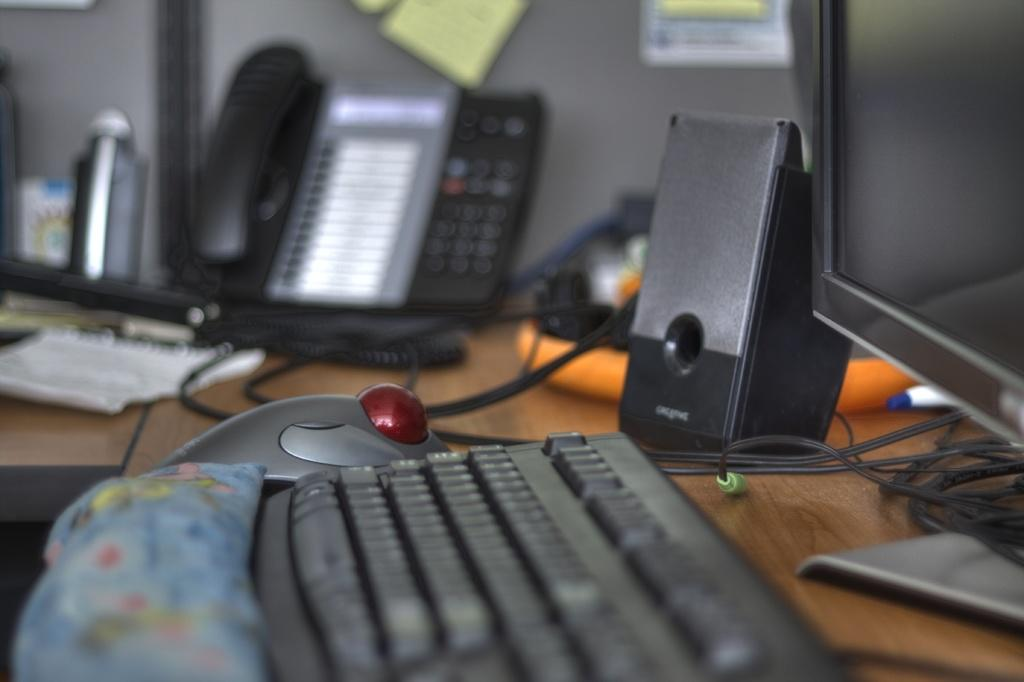What type of furniture is present in the image? There is a table in the image. What electronic device is on the table? There is a monitor on the table. What input device is on the table? There is a keyboard on the table. What pointing device is on the table? There is a mouse on the table. What communication device is on the table? There is a phone on the table. What type of bread is being used as a mousepad in the image? There is no bread present in the image, and therefore no bread being used as a mousepad. What color is the gold phone on the table in the image? There is no gold phone present in the image; the phone is not described as gold. 